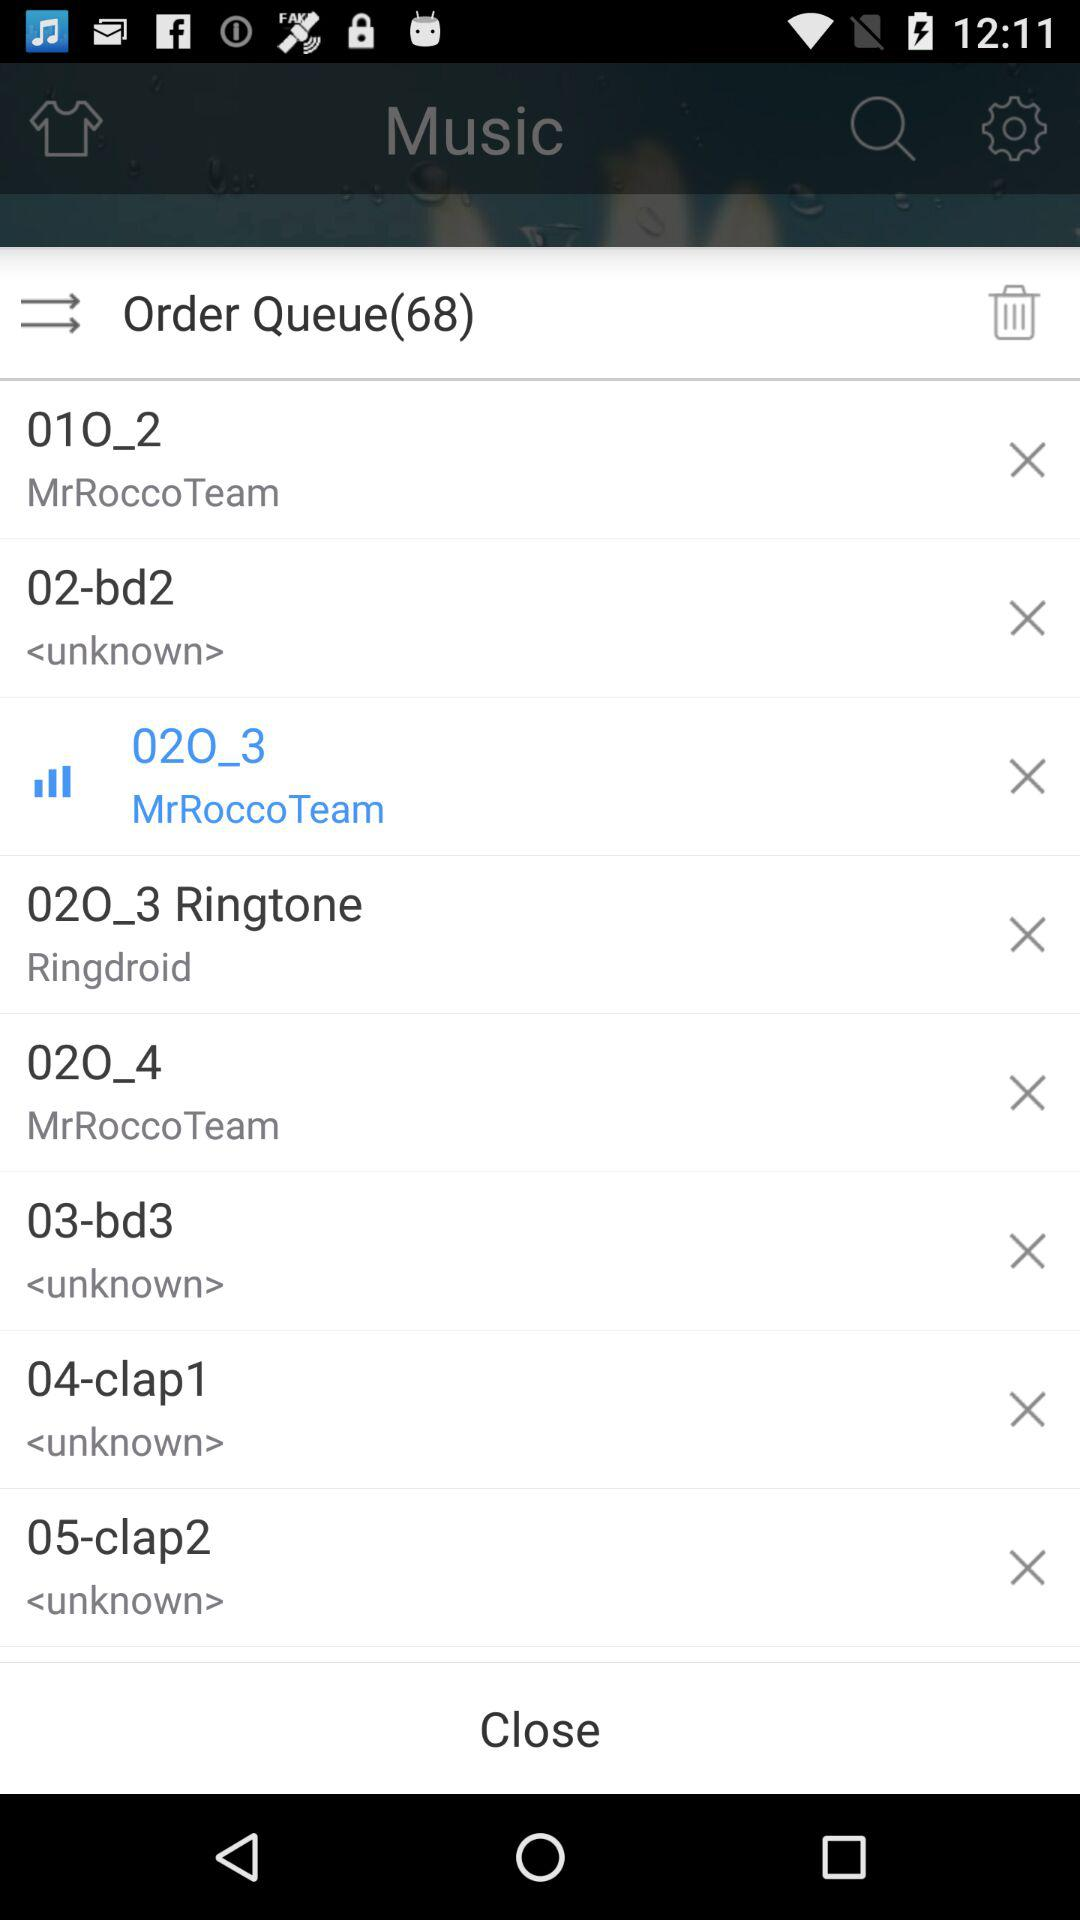How many order queues are there? There are 68 order queues. 